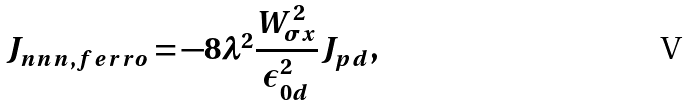<formula> <loc_0><loc_0><loc_500><loc_500>J _ { n n n , f e r r o } = - 8 \lambda ^ { 2 } \frac { W _ { \sigma x } ^ { 2 } } { \epsilon _ { 0 d } ^ { 2 } } J _ { p d } ,</formula> 